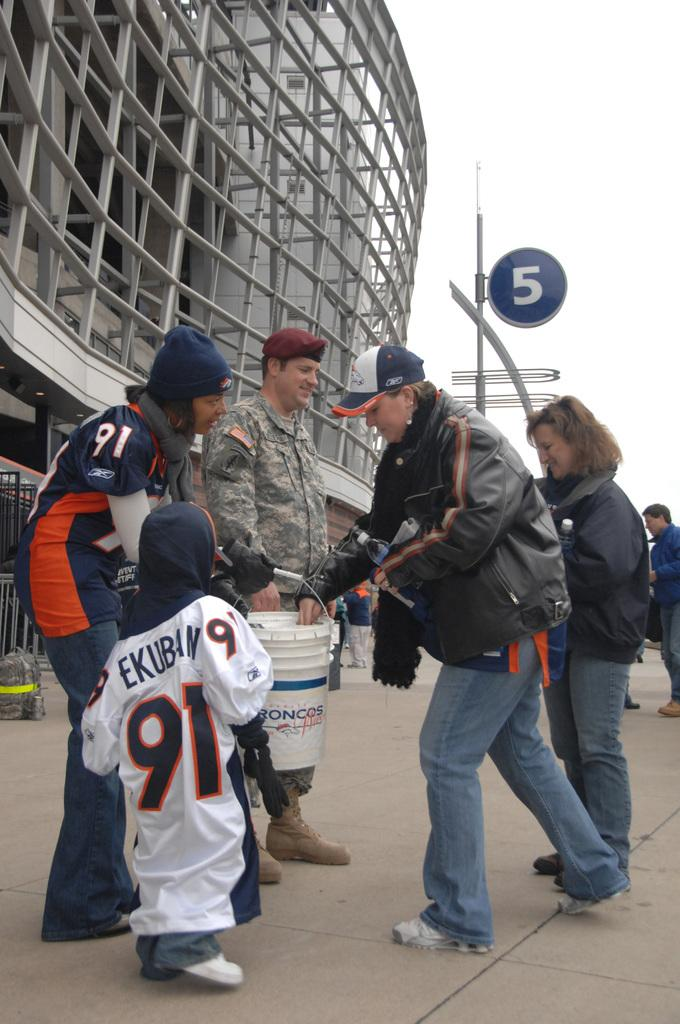How many people are present in the image? There are two men, two women, and a kid in the image, making a total of five people. What is the relationship between the kid and the woman? The kid is standing beside a woman in the image. Who else is standing beside the woman? There is another man standing beside the woman. Where are they standing? They are standing on a path. What can be seen in the background of the image? There is a building and the sky visible in the background of the image. What scientific theory is being discussed by the group in the image? There is no indication in the image that the group is discussing any scientific theory. 